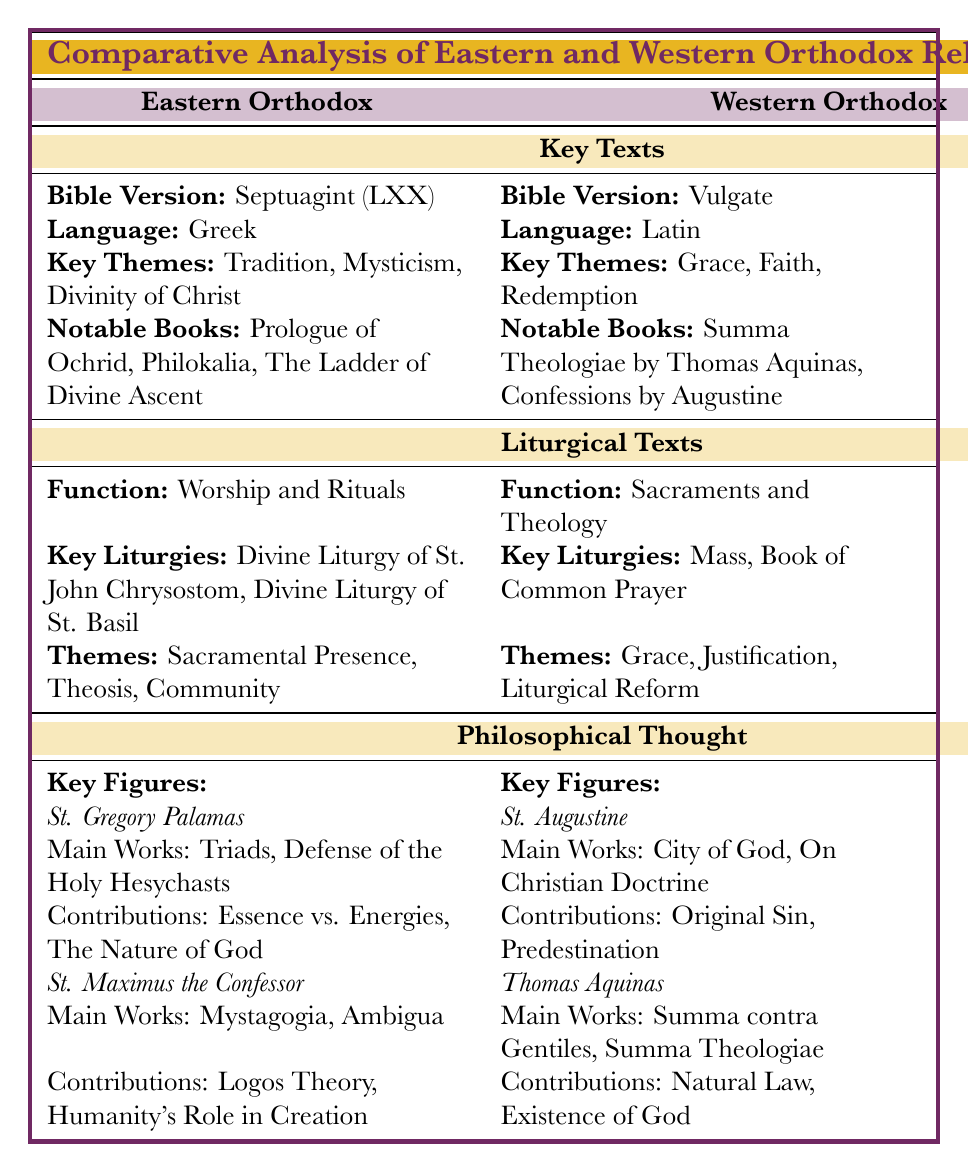What is the Bible version used in the Eastern Orthodox Church? In the table, under the section "Key Texts" for Eastern Orthodox, it states that the Bible version is the Septuagint (LXX).
Answer: Septuagint (LXX) What are the key themes found in the Western Orthodox Bible? From the section describing the Western Orthodox Bible in the table, the key themes listed are Grace, Faith, and Redemption.
Answer: Grace, Faith, Redemption What is the function of the liturgical texts in Eastern Orthodox tradition? The table denotes the function of liturgical texts in Eastern Orthodoxy as "Worship and Rituals."
Answer: Worship and Rituals Who contributed the concept of "Original Sin" in Western Orthodox thought? The table lists St. Augustine as the key figure for the Western Orthodox tradition and specifies that his contributions include "Original Sin."
Answer: St. Augustine How many notable books are mentioned for the Eastern Orthodox Bible? The table shows two notable books listed under Eastern Orthodox Bible: "Prologue of Ochrid" and "Philokalia" along with "The Ladder of Divine Ascent," totaling three books.
Answer: Three Is there a notable difference in the main works between St. Gregory Palamas and St. Augustine? Yes, St. Gregory Palamas has works such as "Triads" and "Defense of the Holy Hesychasts," while St. Augustine has "City of God" and "On Christian Doctrine." Thus, the significant difference is their main works and theological focus.
Answer: Yes Which liturgical themes are shared between the Eastern and Western Orthodox? By examining the themes listed, Eastern Orthodox themes include Sacramental Presence, Theosis, and Community, while Western Orthodox themes encompass Grace, Justification, and Liturgical Reform. Since they do not directly overlap, the answer is that there are no shared themes.
Answer: No shared themes What is the collective focus of the philosophical thought in both Eastern Orthodox and Western Orthodox traditions? To analyze the philosophical contributions, Eastern Orthodox focuses on concepts like Essence vs. Energies by St. Gregory Palamas, whereas Western Orthodox emphasizes Natural Law and the Existence of God by Thomas Aquinas. This indicates differing emphases on God’s nature and law across traditions.
Answer: Different emphases In what language is the Bible version of the Eastern Orthodox Church written? The table specifies that the language of the Eastern Orthodox Bible is Greek.
Answer: Greek Which of the two traditions emphasizes "Grace" more in their key themes? The table indicates that "Grace" is a key theme in the Western Orthodox tradition, suggesting that they emphasize it more. There's no mention of it as a key theme in Eastern Orthodoxy.
Answer: Western Orthodox 